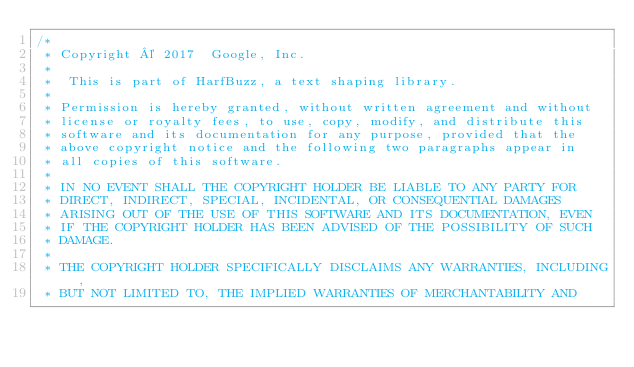Convert code to text. <code><loc_0><loc_0><loc_500><loc_500><_C++_>/*
 * Copyright © 2017  Google, Inc.
 *
 *  This is part of HarfBuzz, a text shaping library.
 *
 * Permission is hereby granted, without written agreement and without
 * license or royalty fees, to use, copy, modify, and distribute this
 * software and its documentation for any purpose, provided that the
 * above copyright notice and the following two paragraphs appear in
 * all copies of this software.
 *
 * IN NO EVENT SHALL THE COPYRIGHT HOLDER BE LIABLE TO ANY PARTY FOR
 * DIRECT, INDIRECT, SPECIAL, INCIDENTAL, OR CONSEQUENTIAL DAMAGES
 * ARISING OUT OF THE USE OF THIS SOFTWARE AND ITS DOCUMENTATION, EVEN
 * IF THE COPYRIGHT HOLDER HAS BEEN ADVISED OF THE POSSIBILITY OF SUCH
 * DAMAGE.
 *
 * THE COPYRIGHT HOLDER SPECIFICALLY DISCLAIMS ANY WARRANTIES, INCLUDING,
 * BUT NOT LIMITED TO, THE IMPLIED WARRANTIES OF MERCHANTABILITY AND</code> 